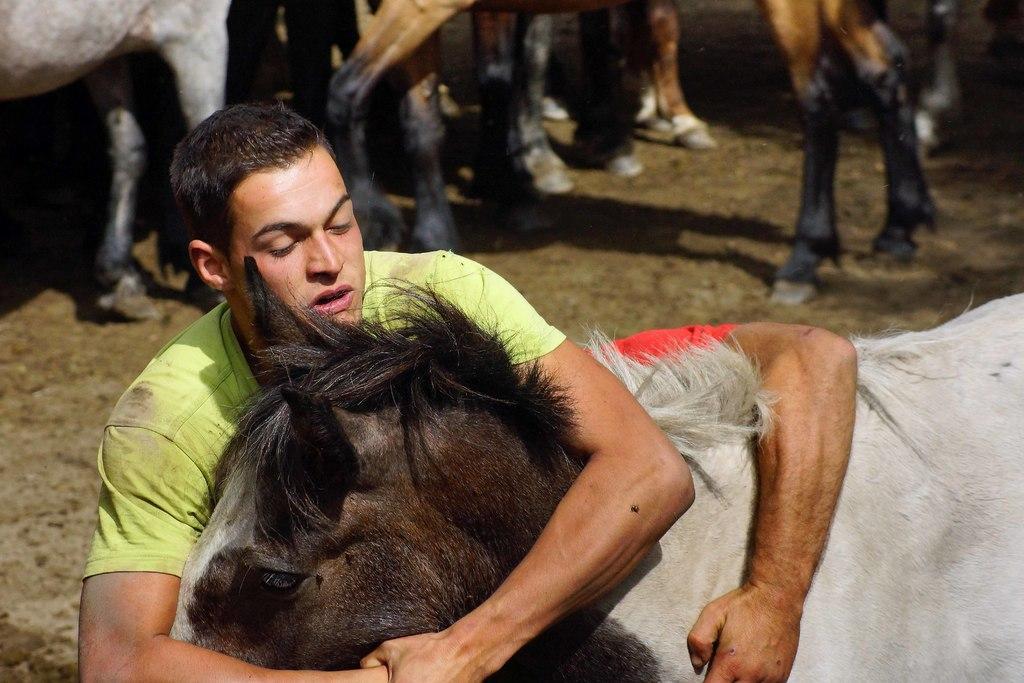In one or two sentences, can you explain what this image depicts? In this picture there is a man with the green t-shirt is holding the animal with his hands. In the background there are some animal legs. 